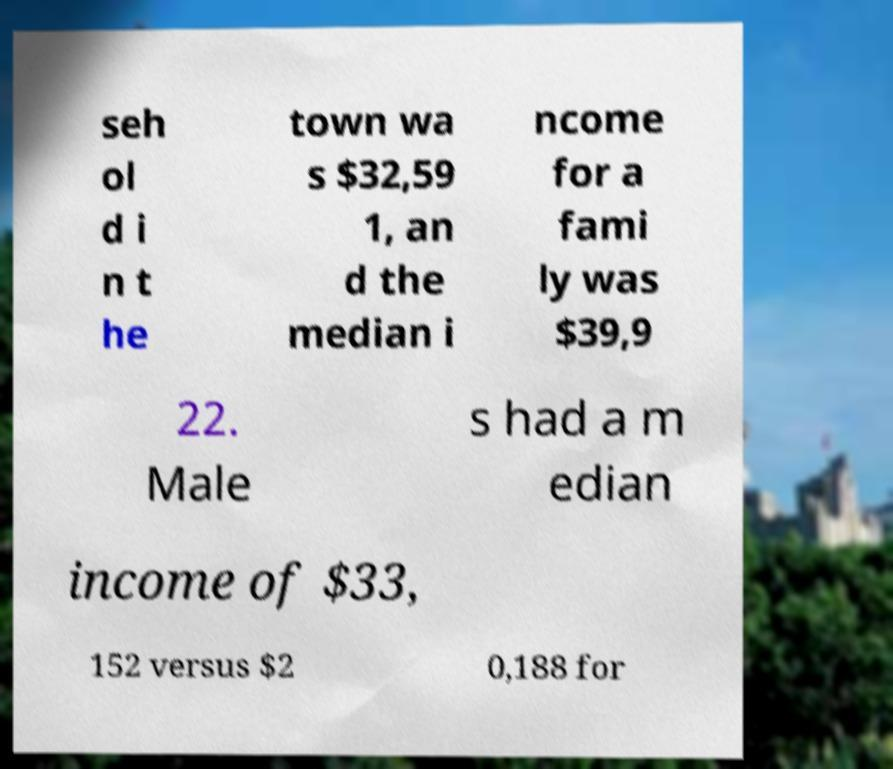Please read and relay the text visible in this image. What does it say? seh ol d i n t he town wa s $32,59 1, an d the median i ncome for a fami ly was $39,9 22. Male s had a m edian income of $33, 152 versus $2 0,188 for 